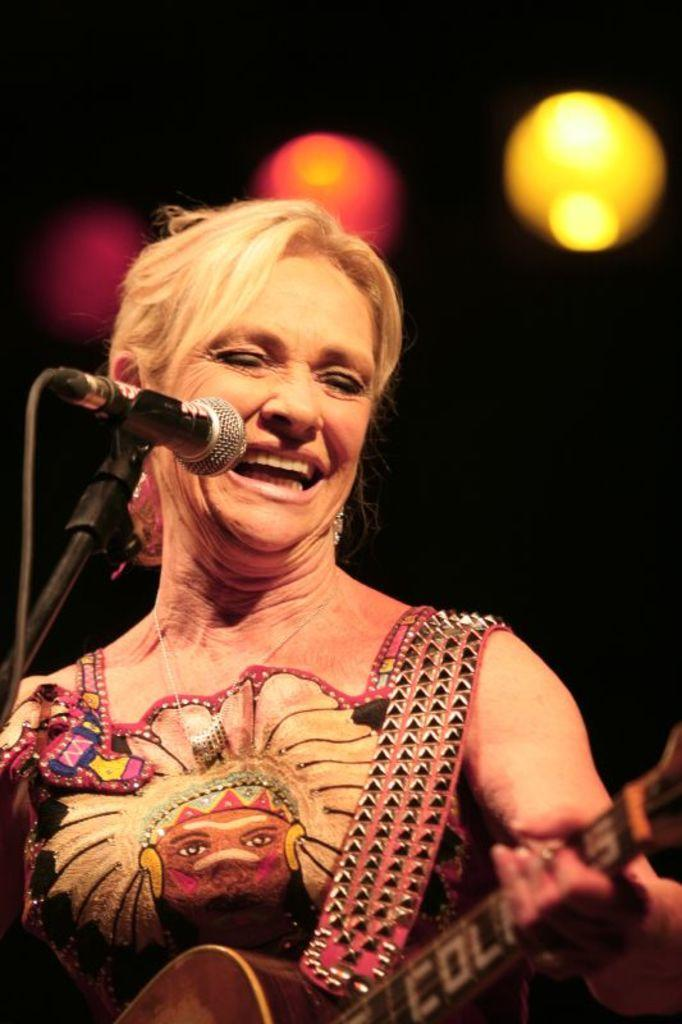What is the person in the image holding? The person is holding a guitar. What is the purpose of the microphone with a stand in the image? The microphone with a stand is likely used for amplifying the person's voice while they play the guitar. What can be seen in the background of the image? There are focusing lights in the background. Reasoning: Let' Let's think step by step in order to produce the conversation. We start by identifying the main subject in the image, which is the person holding a guitar. Then, we expand the conversation to include other items that are also visible, such as the microphone with a stand and the focusing lights in the background. Each question is designed to elicit a specific detail about the image that is known from the provided facts. Absurd Question/Answer: What type of surprise can be seen on the person's face in the image? There is no indication of a surprise or any facial expression on the person's face in the image. 